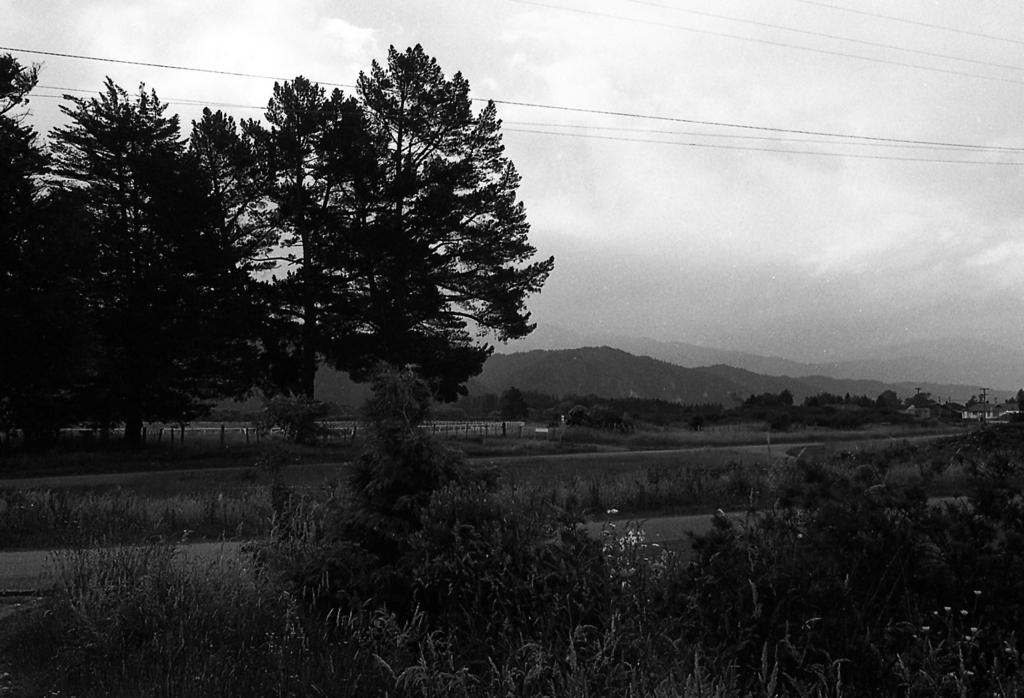What is the color scheme of the image? The image is black and white. What type of natural elements can be seen in the image? There are trees and mountains in the image. What type of tool is being used to build the brick wall in the image? There is no brick wall or tool present in the image; it features trees and mountains in a black and white color scheme. 